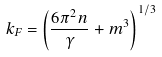<formula> <loc_0><loc_0><loc_500><loc_500>k _ { F } = \left ( \frac { 6 \pi ^ { 2 } n } \gamma + m ^ { 3 } \right ) ^ { 1 / 3 }</formula> 